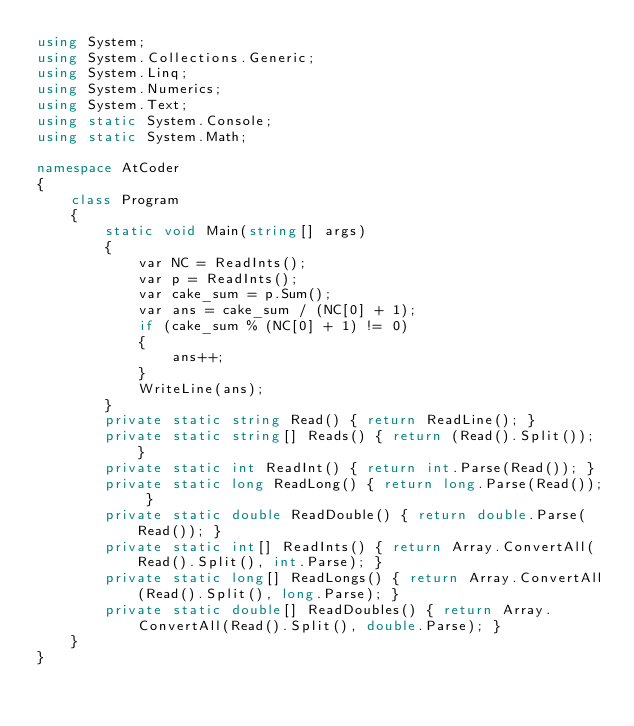<code> <loc_0><loc_0><loc_500><loc_500><_C#_>using System;
using System.Collections.Generic;
using System.Linq;
using System.Numerics;
using System.Text;
using static System.Console;
using static System.Math;

namespace AtCoder
{
    class Program
    {
        static void Main(string[] args)
        {
            var NC = ReadInts();
            var p = ReadInts();
            var cake_sum = p.Sum();
            var ans = cake_sum / (NC[0] + 1);
            if (cake_sum % (NC[0] + 1) != 0)
            {
                ans++;
            }
            WriteLine(ans);
        }
        private static string Read() { return ReadLine(); }
        private static string[] Reads() { return (Read().Split()); }
        private static int ReadInt() { return int.Parse(Read()); }
        private static long ReadLong() { return long.Parse(Read()); }
        private static double ReadDouble() { return double.Parse(Read()); }
        private static int[] ReadInts() { return Array.ConvertAll(Read().Split(), int.Parse); }
        private static long[] ReadLongs() { return Array.ConvertAll(Read().Split(), long.Parse); }
        private static double[] ReadDoubles() { return Array.ConvertAll(Read().Split(), double.Parse); }
    }
}

</code> 